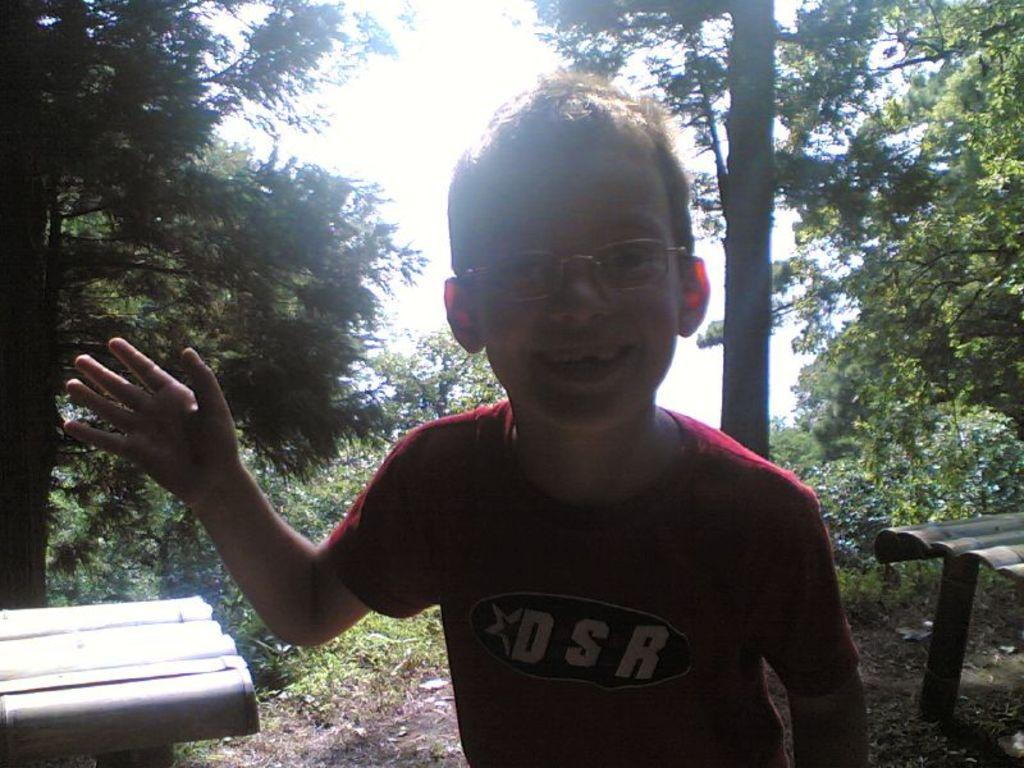What is the person in the image wearing? The person is wearing a maroon color dress in the image. Can you describe any accessories the person is wearing? The person is wearing specs in the image. What type of objects can be seen in the image? There are wooden objects in the image. What can be seen in the background of the image? There are many trees and the sky visible in the background of the image. What type of insect can be seen crawling on the person's dress in the image? There is no insect visible on the person's dress in the image. 